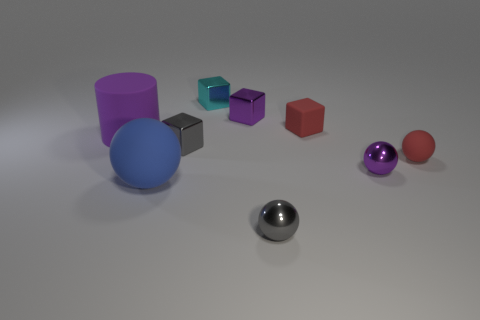Is the color of the rubber block the same as the tiny rubber sphere?
Offer a very short reply. Yes. There is a small shiny ball right of the red cube; is it the same color as the cube in front of the big purple cylinder?
Ensure brevity in your answer.  No. There is a sphere that is left of the cyan metal thing; what is its material?
Ensure brevity in your answer.  Rubber. There is a big cylinder that is the same material as the big blue thing; what color is it?
Your answer should be compact. Purple. How many yellow blocks have the same size as the cyan metallic thing?
Your response must be concise. 0. There is a matte sphere that is on the right side of the blue thing; is it the same size as the small gray metallic cube?
Your answer should be compact. Yes. There is a metallic thing that is both behind the large purple thing and to the right of the cyan thing; what shape is it?
Offer a very short reply. Cube. There is a matte cylinder; are there any purple metallic objects in front of it?
Make the answer very short. Yes. Are there any other things that are the same shape as the purple matte thing?
Keep it short and to the point. No. Is the number of blue balls behind the blue ball the same as the number of tiny purple cubes that are to the left of the big purple object?
Your answer should be very brief. Yes. 